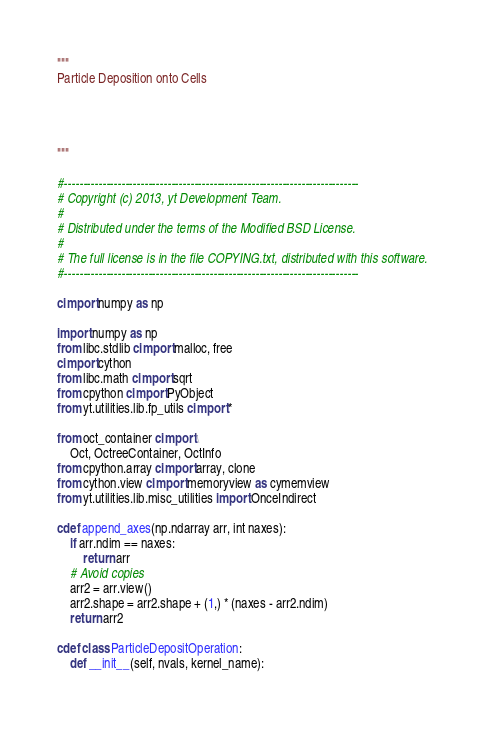<code> <loc_0><loc_0><loc_500><loc_500><_Cython_>"""
Particle Deposition onto Cells




"""

#-----------------------------------------------------------------------------
# Copyright (c) 2013, yt Development Team.
#
# Distributed under the terms of the Modified BSD License.
#
# The full license is in the file COPYING.txt, distributed with this software.
#-----------------------------------------------------------------------------

cimport numpy as np

import numpy as np
from libc.stdlib cimport malloc, free
cimport cython
from libc.math cimport sqrt
from cpython cimport PyObject
from yt.utilities.lib.fp_utils cimport *

from oct_container cimport \
    Oct, OctreeContainer, OctInfo
from cpython.array cimport array, clone
from cython.view cimport memoryview as cymemview
from yt.utilities.lib.misc_utilities import OnceIndirect

cdef append_axes(np.ndarray arr, int naxes):
    if arr.ndim == naxes:
        return arr
    # Avoid copies
    arr2 = arr.view()
    arr2.shape = arr2.shape + (1,) * (naxes - arr2.ndim)
    return arr2

cdef class ParticleDepositOperation:
    def __init__(self, nvals, kernel_name):</code> 